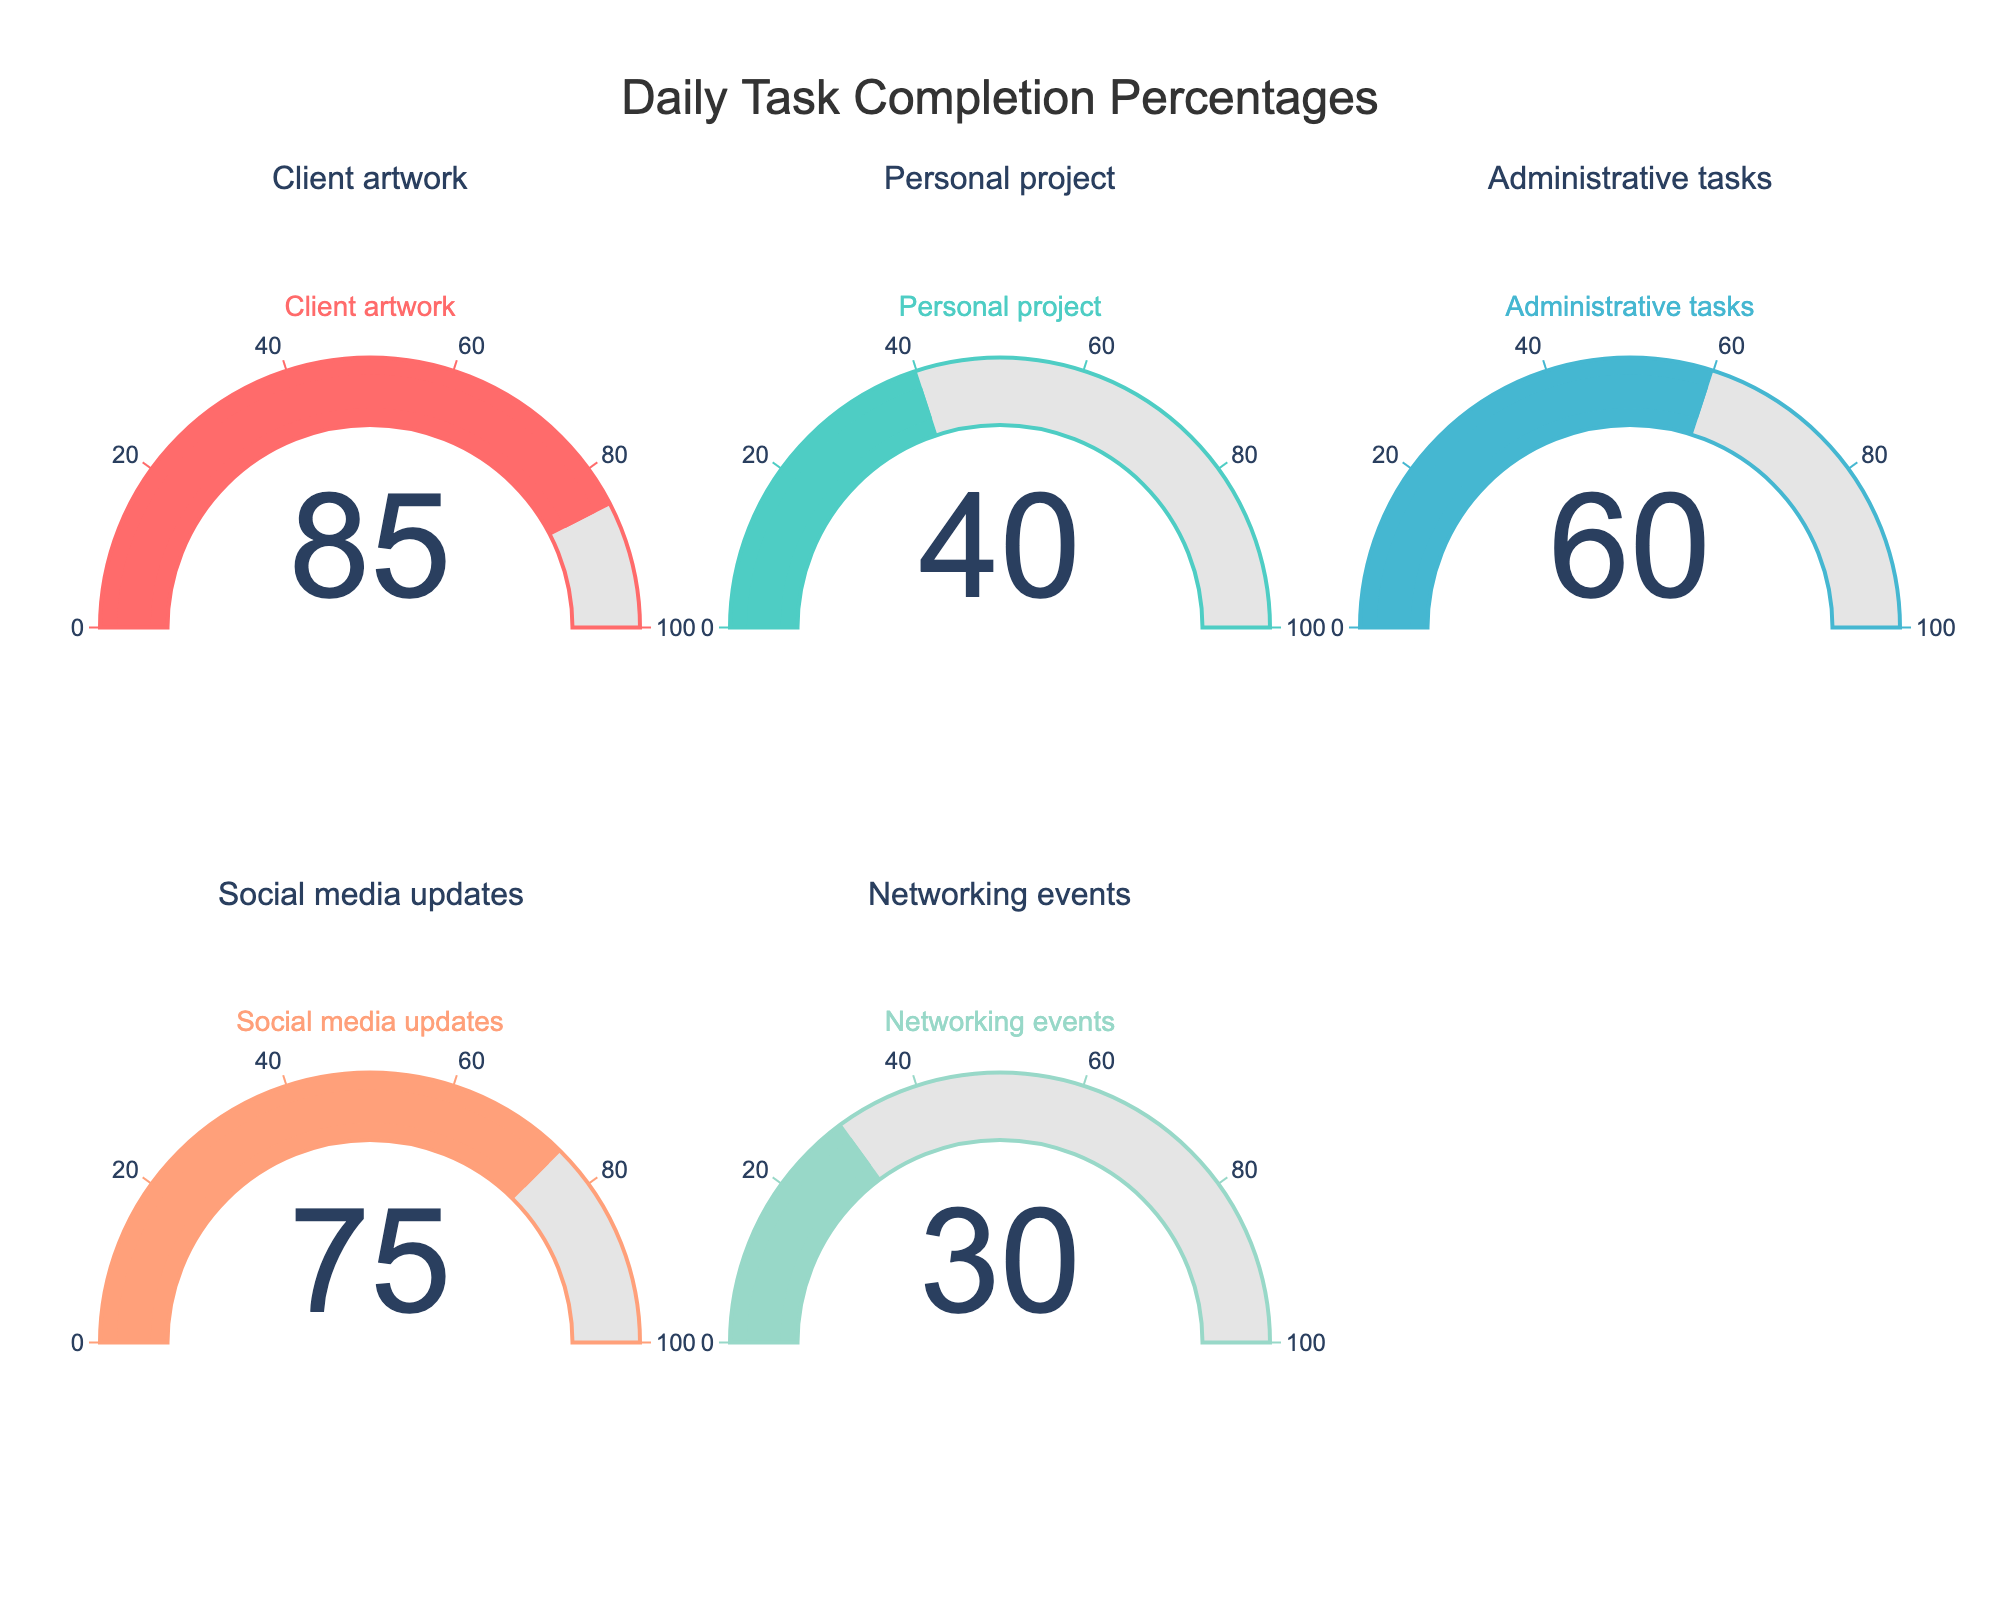What is the completion percentage for Client artwork? The gauge chart for Client artwork shows a completion percentage of 85%.
Answer: 85% What task has the lowest completion percentage? By looking at the gauges, the task with the lowest completion percentage is Networking events with 30%.
Answer: Networking events What's the difference in completion percentage between Client artwork and Personal project? The completion percentage for Client artwork is 85%, and for Personal project, it is 40%. The difference is 85 - 40 = 45%.
Answer: 45% Which task has a completion percentage higher than 70%? The tasks with completion percentages higher than 70% are Client artwork (85%) and Social media updates (75%).
Answer: Client artwork, Social media updates What is the average completion percentage of all tasks? To calculate the average, add all completion percentages and divide by the number of tasks: (85 + 40 + 60 + 75 + 30) / 5 = 58%.
Answer: 58% Which colors are used to represent the completion percentages? The colors used to represent the completion percentages are pink (Client artwork), teal (Personal project), cyan (Administrative tasks), light coral (Social media updates), and mint (Networking events).
Answer: Pink, teal, cyan, light coral, mint How many tasks have a completion percentage below 50%? The tasks with completion percentages below 50% are Personal project (40%) and Networking events (30%). There are 2 such tasks.
Answer: 2 What is the total completion percentage for Administrative tasks and Social media updates combined? The completion percentages for Administrative tasks is 60% and Social media updates is 75%. The sum is 60 + 75 = 135%.
Answer: 135% Compare the completion percentages of Personal project and Administrative tasks. Which one is higher? The completion percentage for Personal project is 40% while for Administrative tasks it is 60%. The higher percentage is for Administrative tasks.
Answer: Administrative tasks 